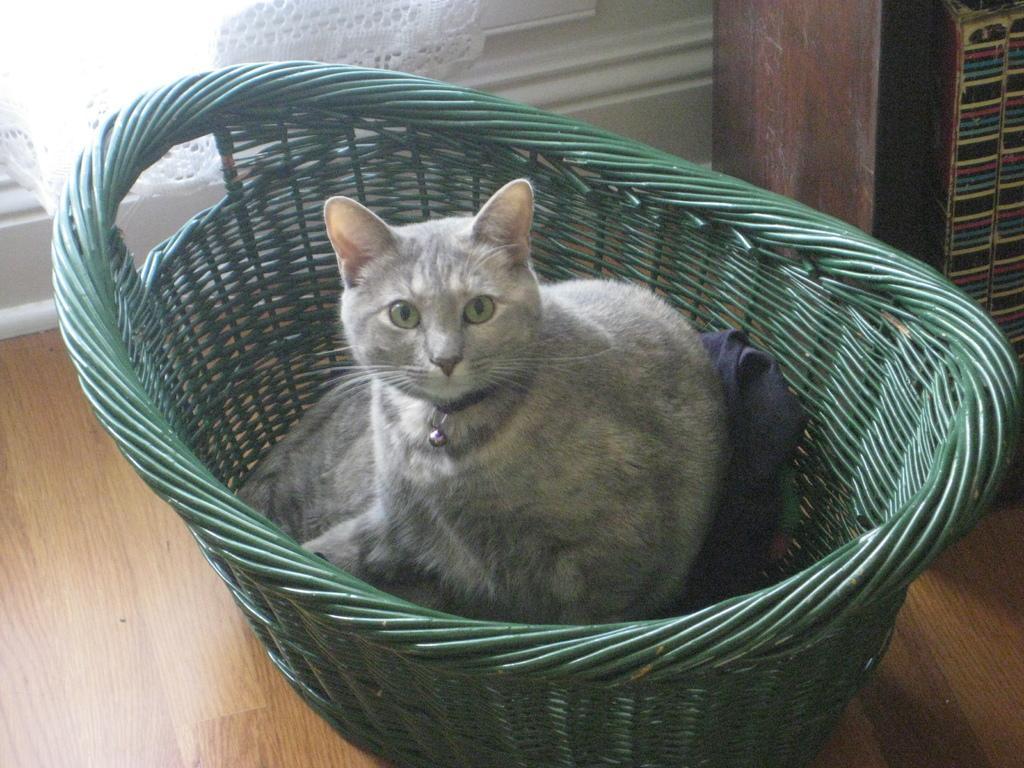Describe this image in one or two sentences. In the center of the picture there is a green basket, in the basket there is a cat. At the top left there is a curtain and a window. On the right there is a wooden object. 